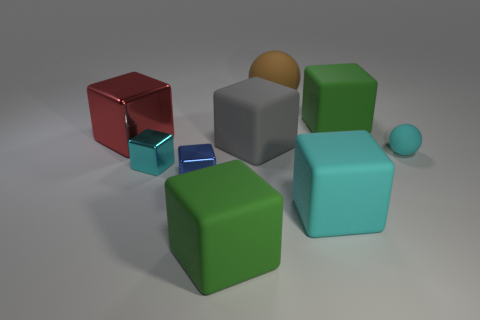Subtract all big green blocks. How many blocks are left? 5 Subtract all red blocks. How many blocks are left? 6 Subtract 2 cubes. How many cubes are left? 5 Subtract all red cubes. Subtract all yellow spheres. How many cubes are left? 6 Subtract all cubes. How many objects are left? 2 Add 3 large rubber balls. How many large rubber balls are left? 4 Add 8 small blocks. How many small blocks exist? 10 Subtract 0 purple spheres. How many objects are left? 9 Subtract all big blue metallic balls. Subtract all green cubes. How many objects are left? 7 